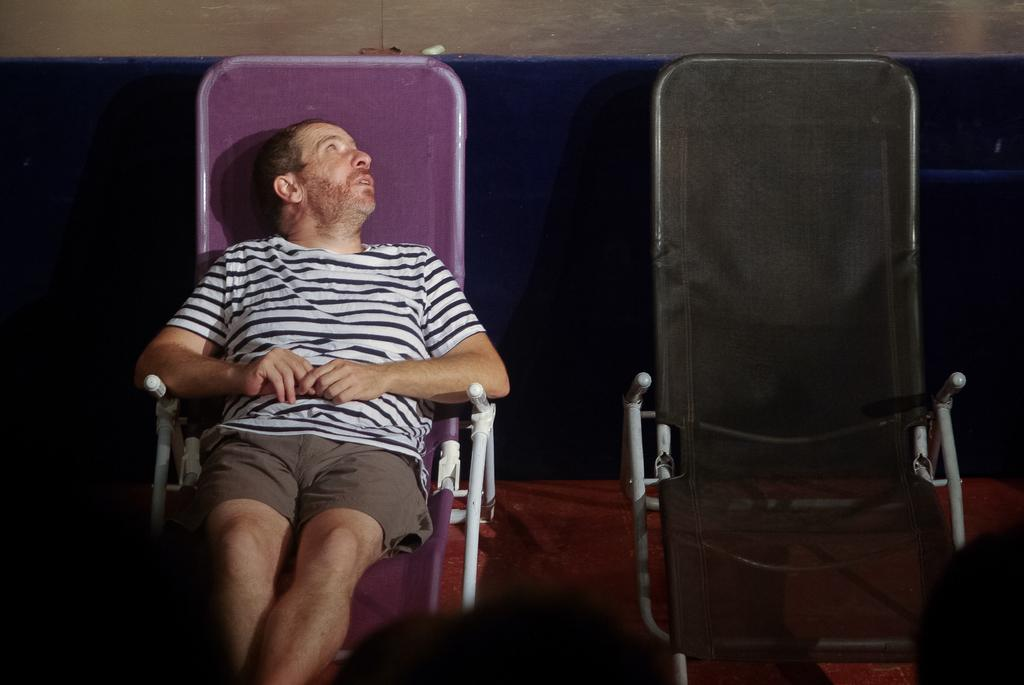What is the man in the image doing? The man is sitting on a chair in the image. How many chairs are visible in the image? There are chairs in the image. What can be seen beneath the chairs in the image? The floor is visible in the image. What is visible behind the chairs in the image? There is a wall in the background of the image. What is the man's tendency to hydrate during the minute shown in the image? There is no information about the man's hydration habits or the duration of the scene in the image, so it cannot be determined from the image. 